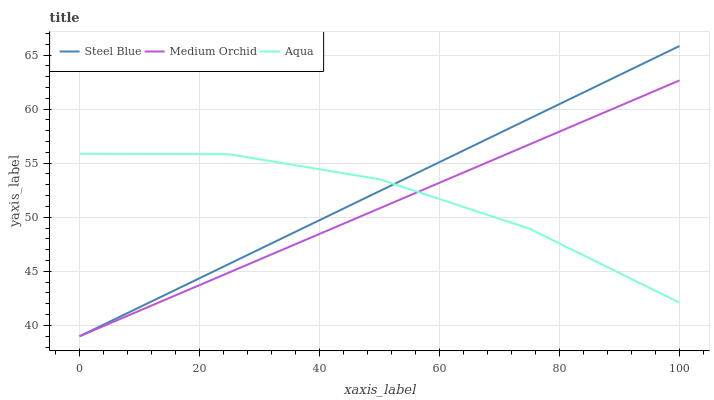Does Aqua have the minimum area under the curve?
Answer yes or no. No. Does Aqua have the maximum area under the curve?
Answer yes or no. No. Is Steel Blue the smoothest?
Answer yes or no. No. Is Steel Blue the roughest?
Answer yes or no. No. Does Aqua have the lowest value?
Answer yes or no. No. Does Aqua have the highest value?
Answer yes or no. No. 